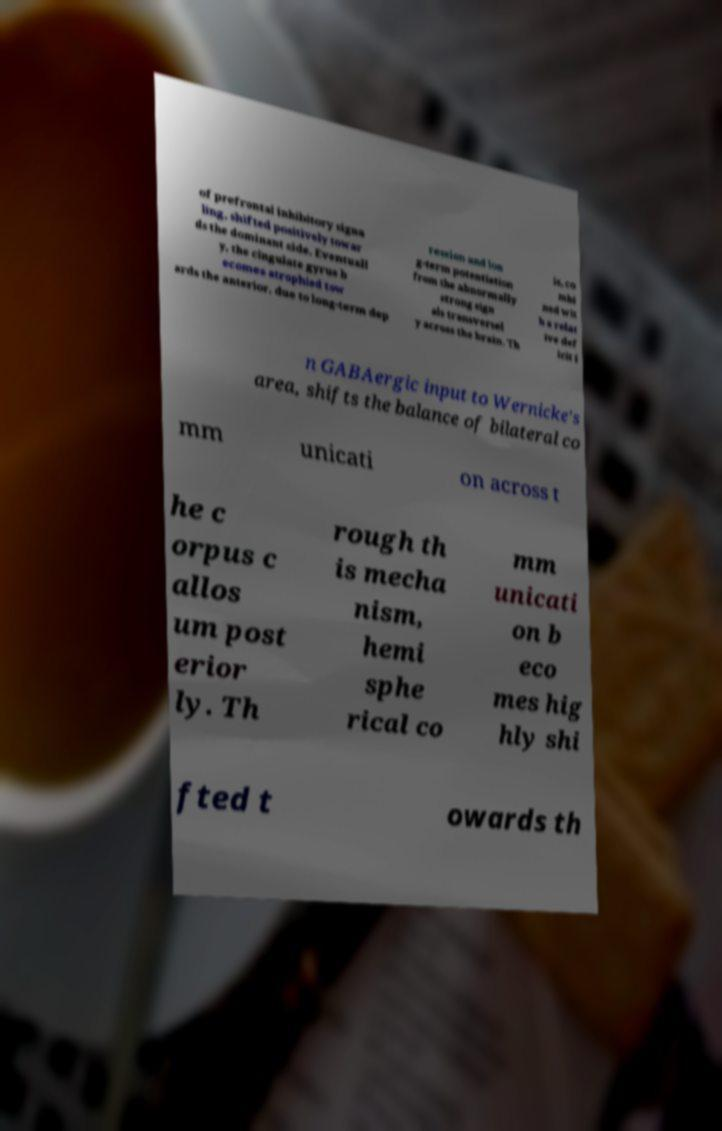Can you accurately transcribe the text from the provided image for me? of prefrontal inhibitory signa ling, shifted positively towar ds the dominant side. Eventuall y, the cingulate gyrus b ecomes atrophied tow ards the anterior, due to long-term dep ression and lon g-term potentiation from the abnormally strong sign als transversel y across the brain. Th is, co mbi ned wit h a relat ive def icit i n GABAergic input to Wernicke's area, shifts the balance of bilateral co mm unicati on across t he c orpus c allos um post erior ly. Th rough th is mecha nism, hemi sphe rical co mm unicati on b eco mes hig hly shi fted t owards th 